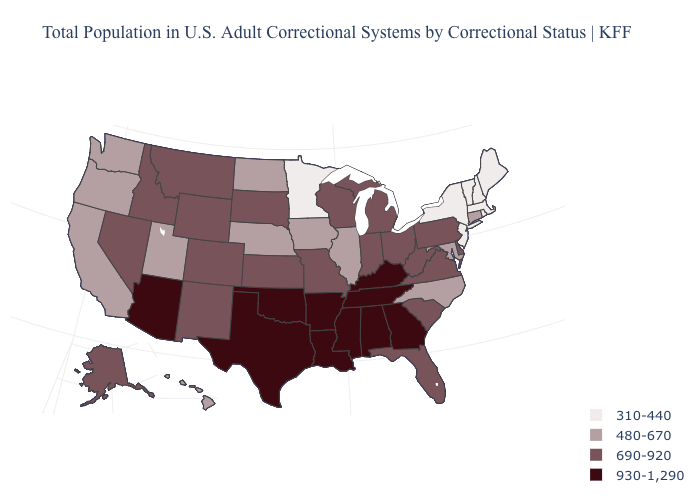What is the value of West Virginia?
Concise answer only. 690-920. Does the map have missing data?
Give a very brief answer. No. Name the states that have a value in the range 690-920?
Quick response, please. Alaska, Colorado, Delaware, Florida, Idaho, Indiana, Kansas, Michigan, Missouri, Montana, Nevada, New Mexico, Ohio, Pennsylvania, South Carolina, South Dakota, Virginia, West Virginia, Wisconsin, Wyoming. Does Texas have a higher value than Kentucky?
Give a very brief answer. No. Does the map have missing data?
Quick response, please. No. Which states have the lowest value in the USA?
Answer briefly. Maine, Massachusetts, Minnesota, New Hampshire, New Jersey, New York, Rhode Island, Vermont. Does Illinois have a higher value than Connecticut?
Be succinct. No. Name the states that have a value in the range 930-1,290?
Be succinct. Alabama, Arizona, Arkansas, Georgia, Kentucky, Louisiana, Mississippi, Oklahoma, Tennessee, Texas. Does the first symbol in the legend represent the smallest category?
Be succinct. Yes. What is the highest value in the USA?
Concise answer only. 930-1,290. Which states have the lowest value in the MidWest?
Concise answer only. Minnesota. What is the highest value in the USA?
Answer briefly. 930-1,290. What is the value of Utah?
Answer briefly. 480-670. What is the value of Utah?
Give a very brief answer. 480-670. What is the value of Delaware?
Quick response, please. 690-920. 